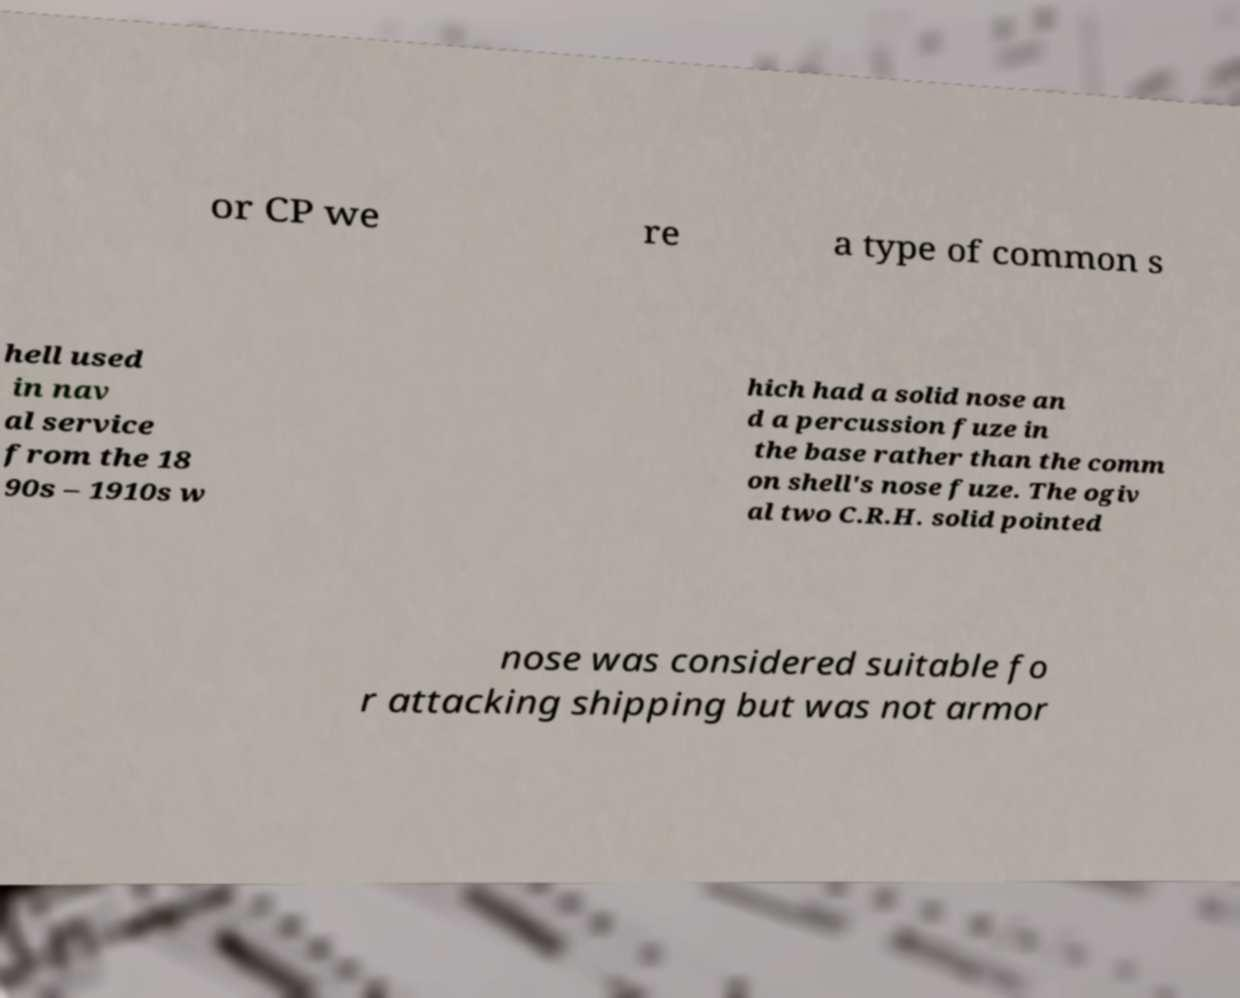Please read and relay the text visible in this image. What does it say? or CP we re a type of common s hell used in nav al service from the 18 90s – 1910s w hich had a solid nose an d a percussion fuze in the base rather than the comm on shell's nose fuze. The ogiv al two C.R.H. solid pointed nose was considered suitable fo r attacking shipping but was not armor 